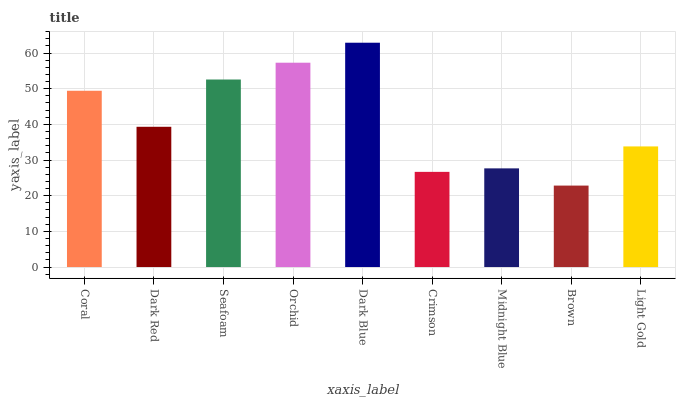Is Brown the minimum?
Answer yes or no. Yes. Is Dark Blue the maximum?
Answer yes or no. Yes. Is Dark Red the minimum?
Answer yes or no. No. Is Dark Red the maximum?
Answer yes or no. No. Is Coral greater than Dark Red?
Answer yes or no. Yes. Is Dark Red less than Coral?
Answer yes or no. Yes. Is Dark Red greater than Coral?
Answer yes or no. No. Is Coral less than Dark Red?
Answer yes or no. No. Is Dark Red the high median?
Answer yes or no. Yes. Is Dark Red the low median?
Answer yes or no. Yes. Is Light Gold the high median?
Answer yes or no. No. Is Coral the low median?
Answer yes or no. No. 